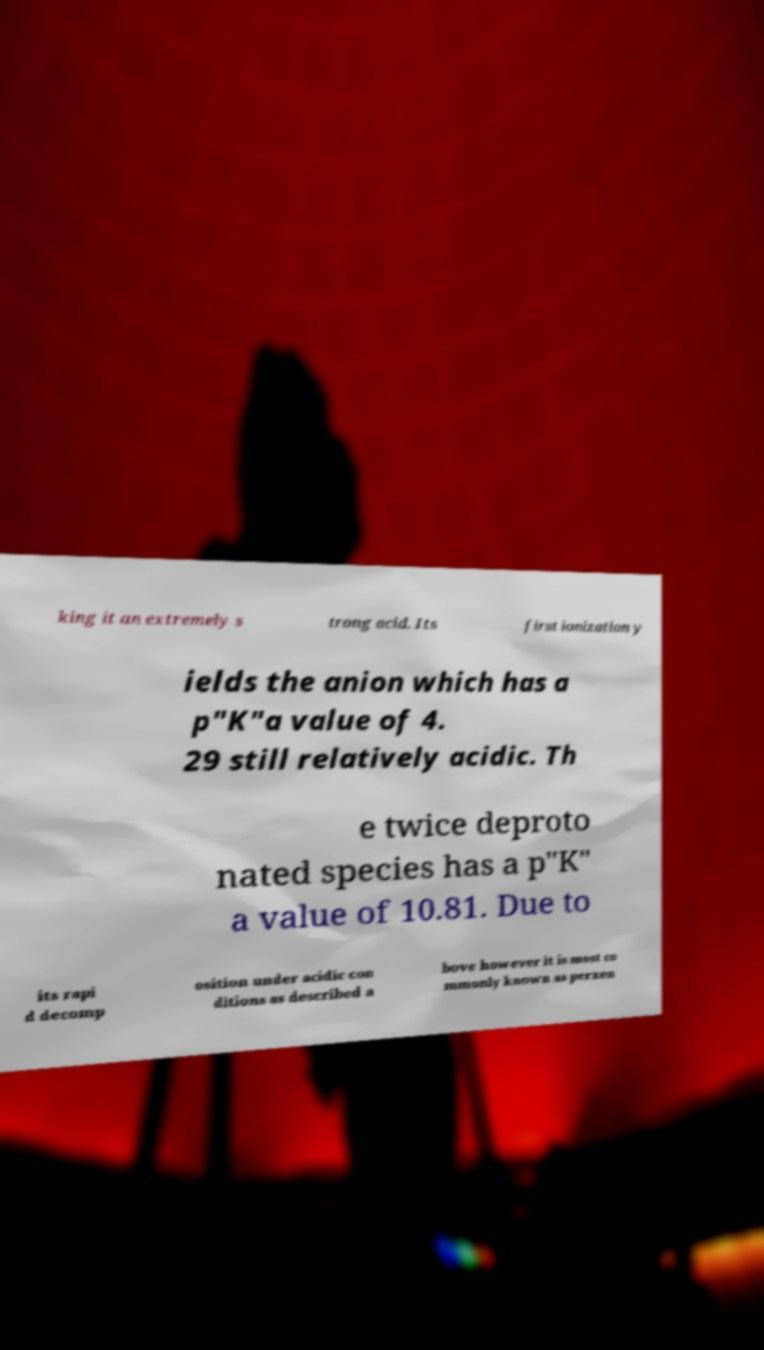Can you accurately transcribe the text from the provided image for me? king it an extremely s trong acid. Its first ionization y ields the anion which has a p"K"a value of 4. 29 still relatively acidic. Th e twice deproto nated species has a p"K" a value of 10.81. Due to its rapi d decomp osition under acidic con ditions as described a bove however it is most co mmonly known as perxen 